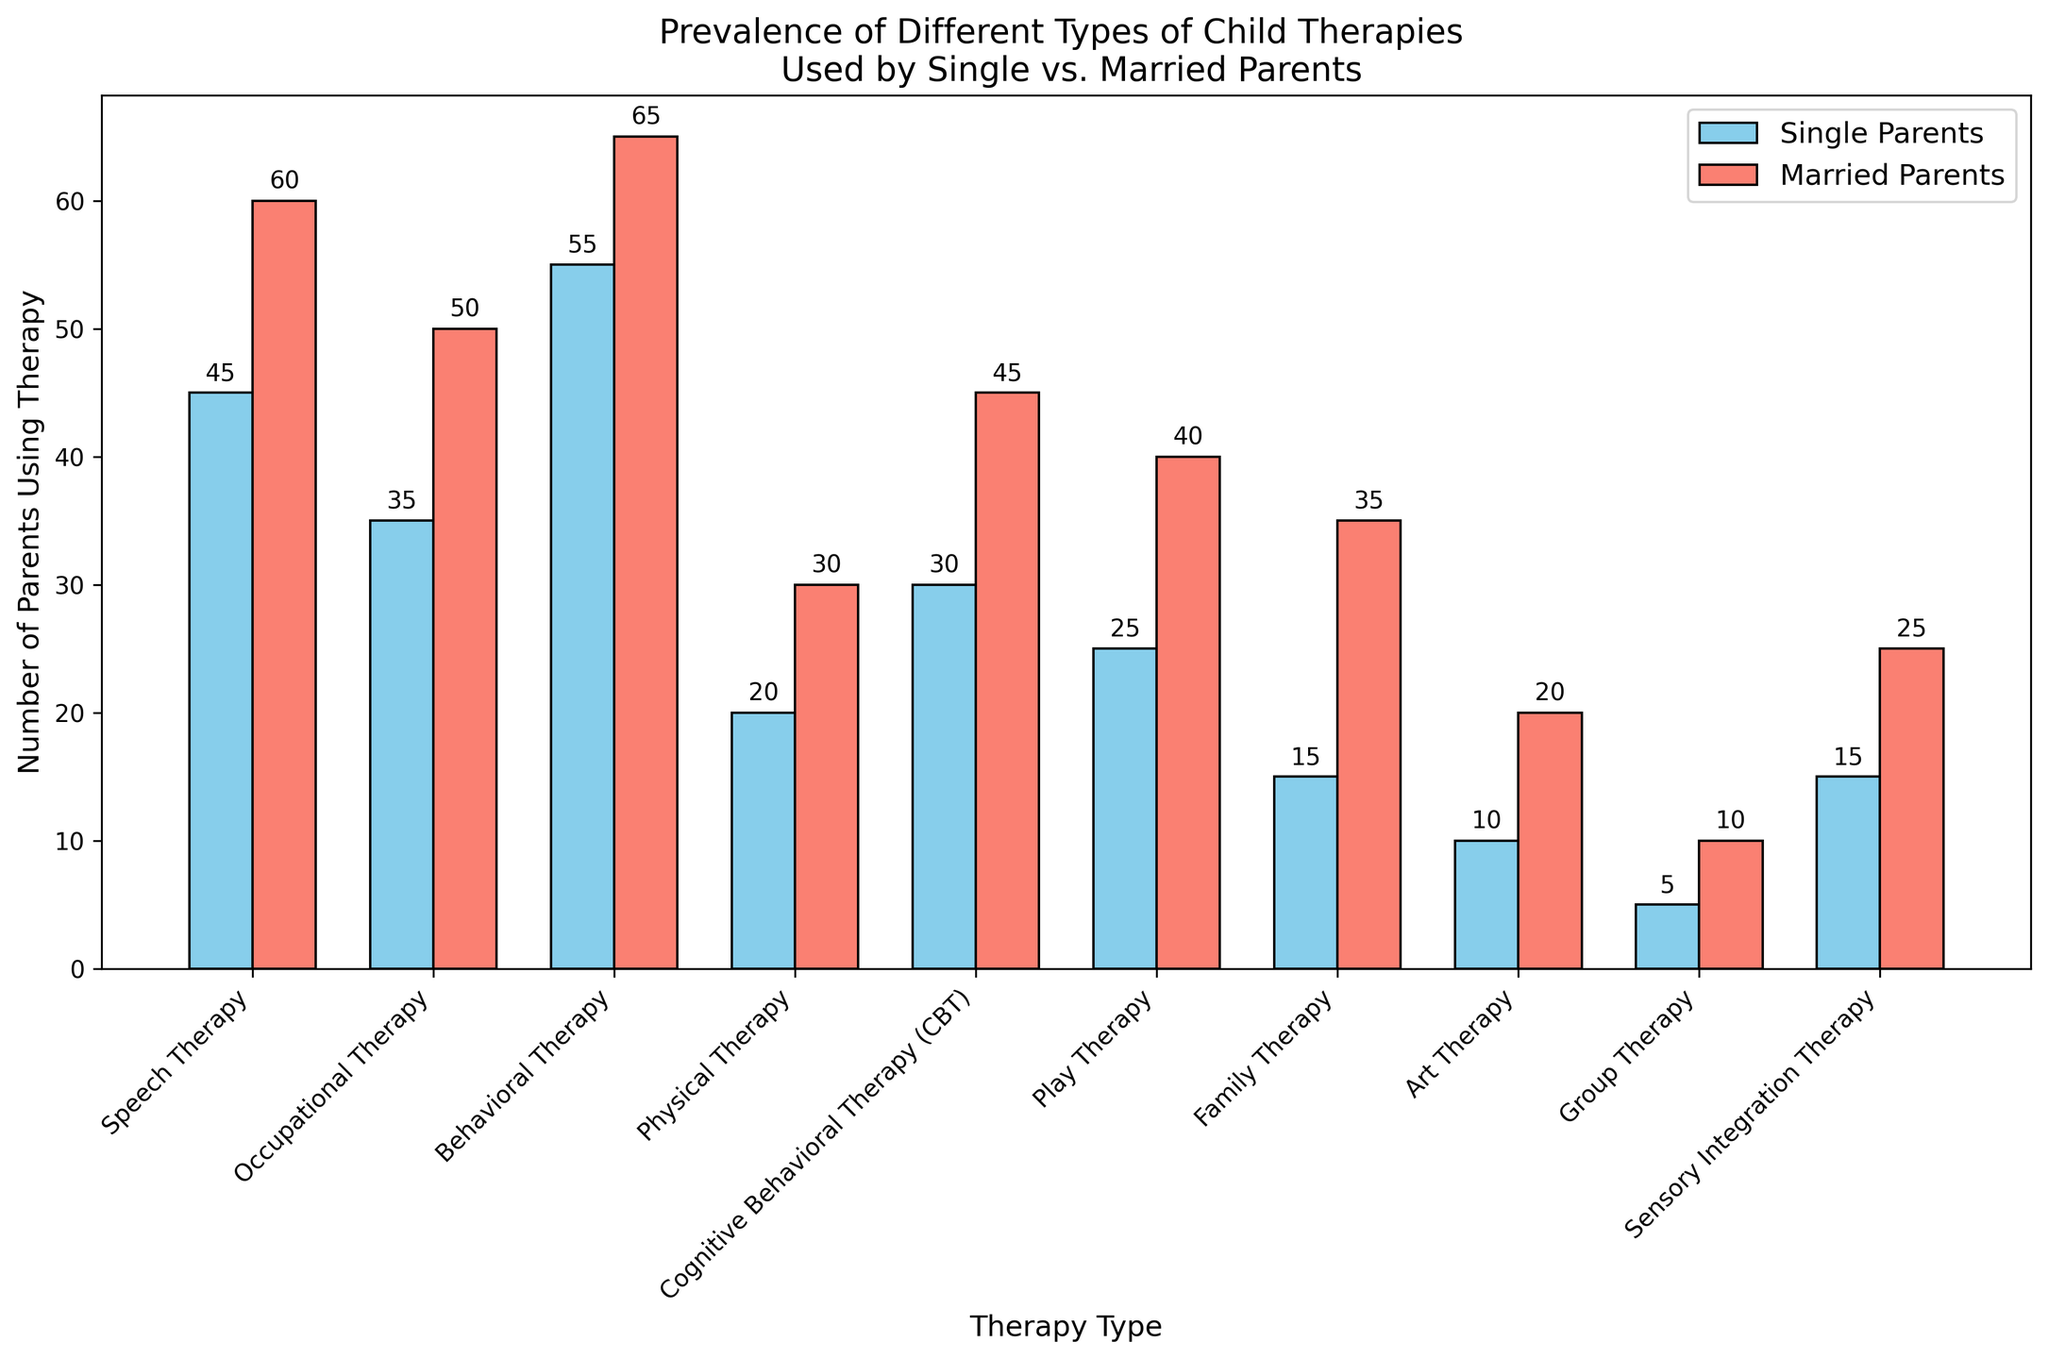What is the most commonly used therapy type among single parents? By looking at the height of the bars that represent single parents, the tallest one corresponds to Behavioral Therapy.
Answer: Behavioral Therapy Which therapy type has the largest difference in prevalence between single and married parents? The height difference between single and married parents' bars is greatest for Family Therapy.
Answer: Family Therapy How many more married parents use Play Therapy compared to single parents? To find this, subtract the number of single parents using Play Therapy (25) from the number of married parents using it (40). 40 - 25 = 15
Answer: 15 For how many therapy types do married parents have higher usage compared to single parents? By visually comparing the heights of the bars, married parents have higher usage for all therapy types listed. Count the types: 10
Answer: 10 What is the combined total number of parents using Speech Therapy? Add the number of single parents (45) and married parents (60) using Speech Therapy. 45 + 60 = 105
Answer: 105 Which therapy type is used by the least number of single parents? The shortest bar for single parents corresponds to Group Therapy.
Answer: Group Therapy What is the ratio of single parents to married parents using Cognitive Behavioral Therapy (CBT)? Single parents using CBT are 30, and married parents are 45. The ratio is 30:45 which can be simplified to 2:3.
Answer: 2:3 Is the sum of single parents using Art Therapy and Sensory Integration Therapy greater than the number of married parents using Play Therapy? Calculate the sum of single parents using Art Therapy (10) and Sensory Integration Therapy (15), which is 10 + 15 = 25. Compare it to the number of married parents using Play Therapy (40). 25 < 40
Answer: No Which therapy type shows equal usage among single and married parents? By looking at the height of the bars, there is no therapy type where single and married parents have equal usage.
Answer: None 